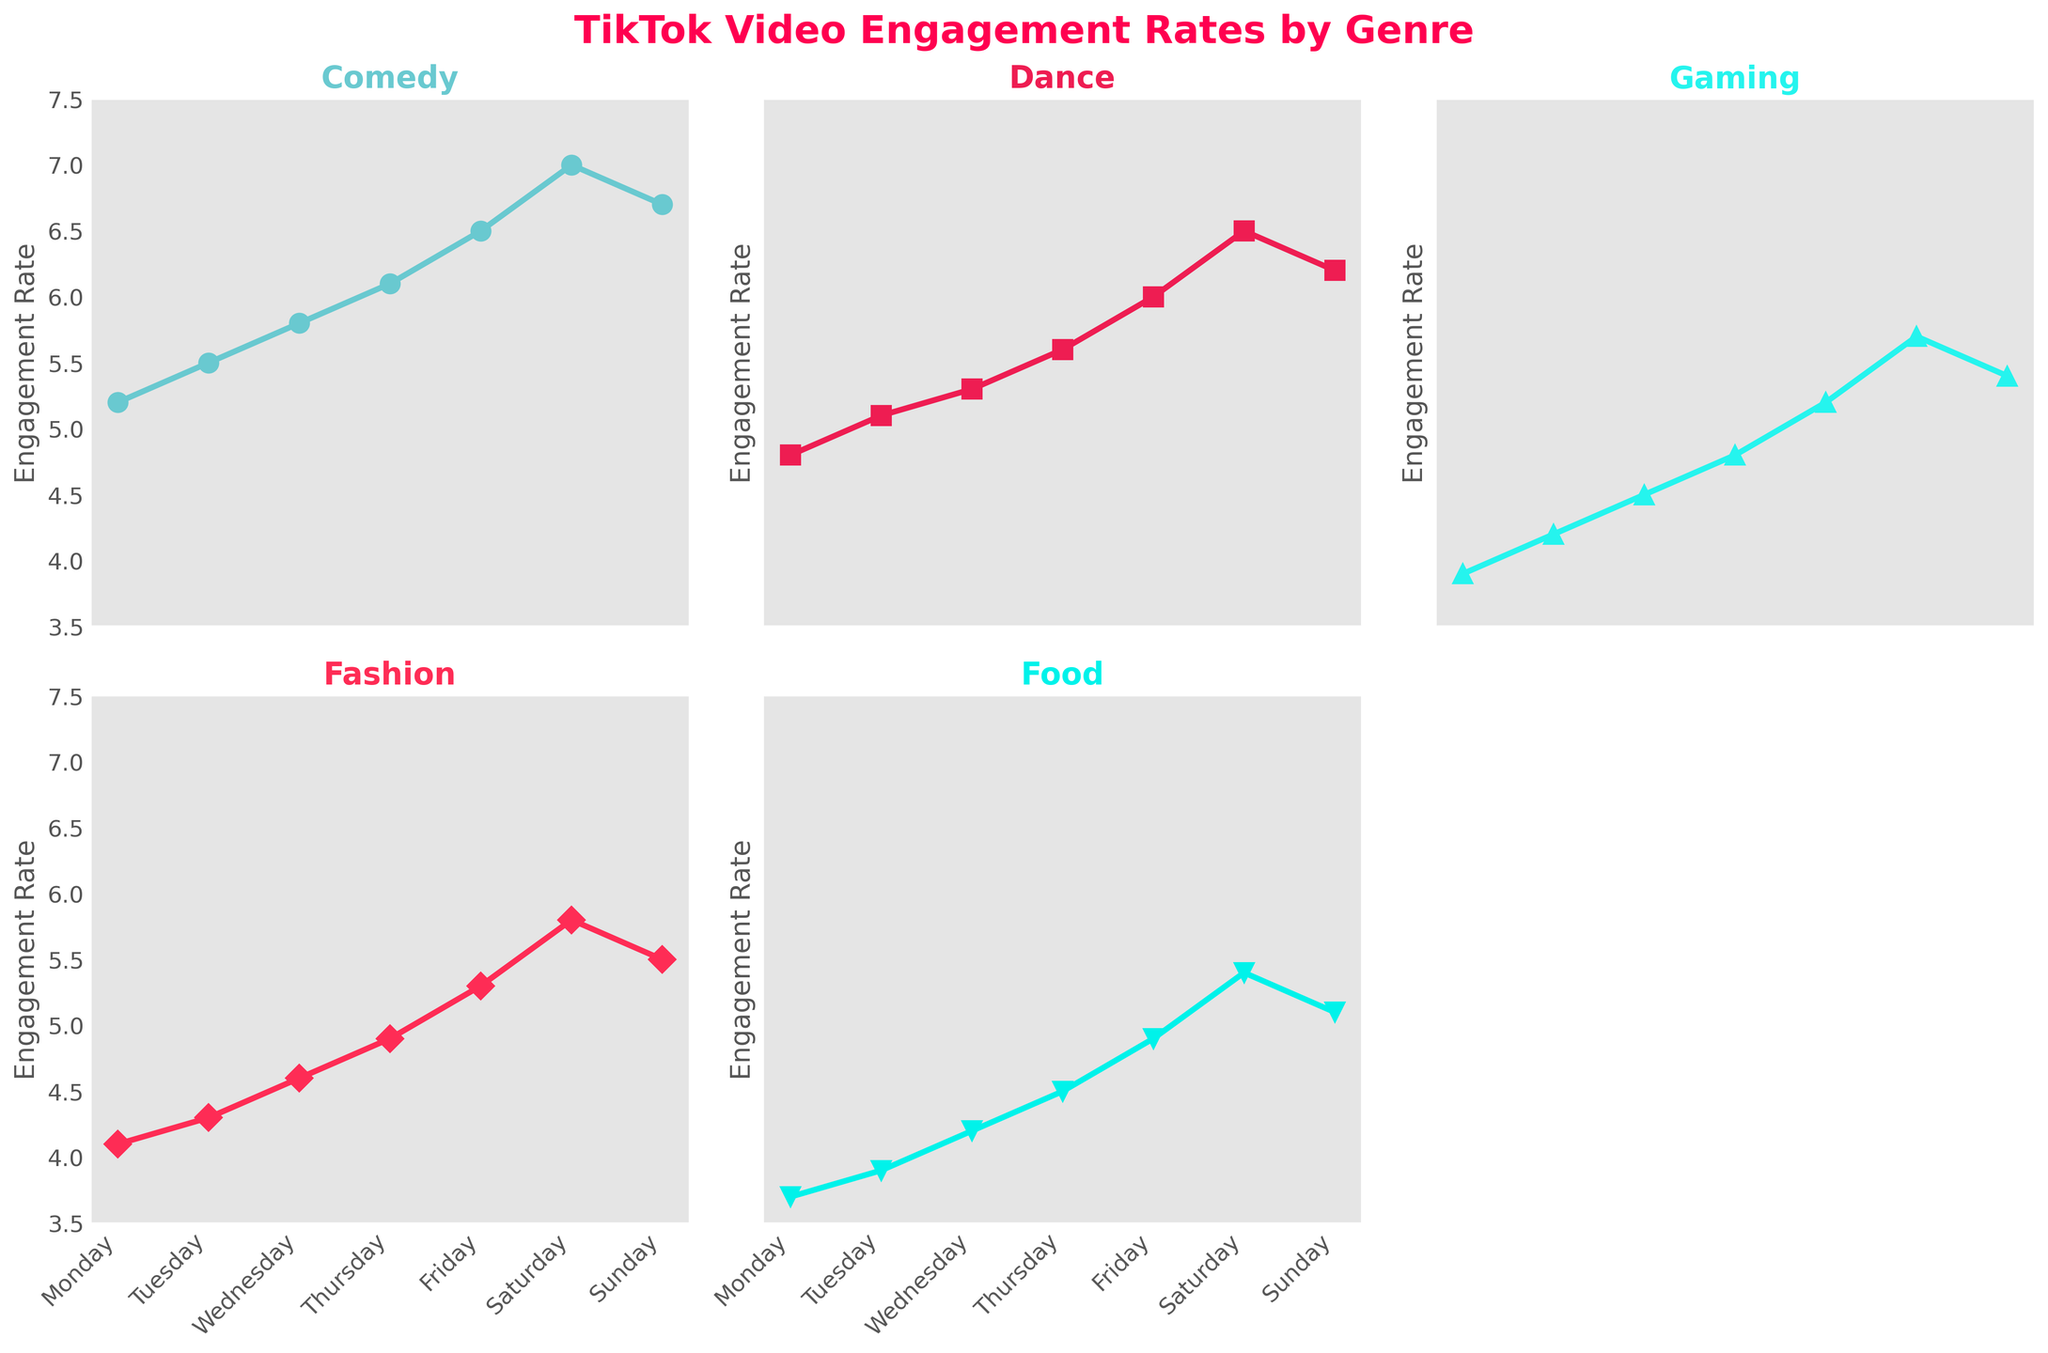Which genre has the highest engagement rate on Saturday? On Saturday, Comedy has an engagement rate of 7.0 which is the highest among all genres.
Answer: Comedy What is the engagement rate for Food on Wednesday? Refer to the Food plot's data points and find the value corresponding to Wednesday, which is 4.2.
Answer: 4.2 Which day shows the highest engagement rate for Dance videos? Look at the peak point in the Dance plot, which is on Saturday with an engagement rate of 6.5.
Answer: Saturday From Monday to Friday, which genre shows the most consistent increase in engagement rate? By observing all genres, Comedy shows a steady rise from 5.2 on Monday to 6.5 on Friday.
Answer: Comedy How many genres have an engagement rate greater than 5.0 on Sunday? On Sunday, Comedy (6.7), Dance (6.2), Gaming (5.4), and Fashion (5.5) have rates above 5.0.
Answer: 4 What is the average engagement rate for Fashion videos over the week? Sum the engagement rates for Fashion: 4.1 + 4.3 + 4.6 + 4.9 + 5.3 + 5.8 + 5.5 = 34.5, then divide by 7 (days in a week).
Answer: 4.93 On which day does Gaming have its highest engagement rate? The peak engagement rate for Gaming is 5.7, which occurs on Saturday.
Answer: Saturday Compare the engagement rates for Food videos on Monday and Friday. Which day has a higher rate? Food has an engagement rate of 3.7 on Monday and 4.9 on Friday. Friday is higher.
Answer: Friday What is the minimum engagement rate for Dance videos throughout the week? The lowest point in the Dance plot is on Monday with an engagement rate of 4.8.
Answer: 4.8 